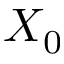Convert formula to latex. <formula><loc_0><loc_0><loc_500><loc_500>X _ { 0 }</formula> 